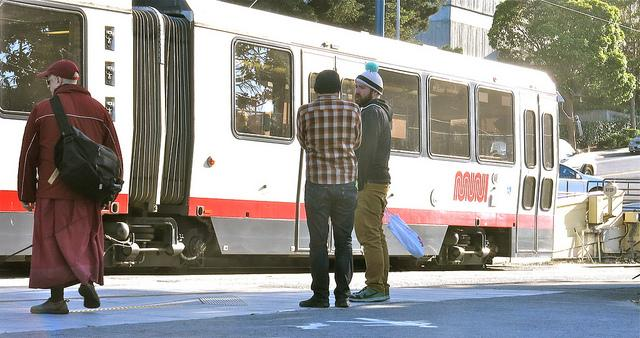What transmits electrical energy to the locomotive here? Please explain your reasoning. overhead line. Electric cables are visible. 